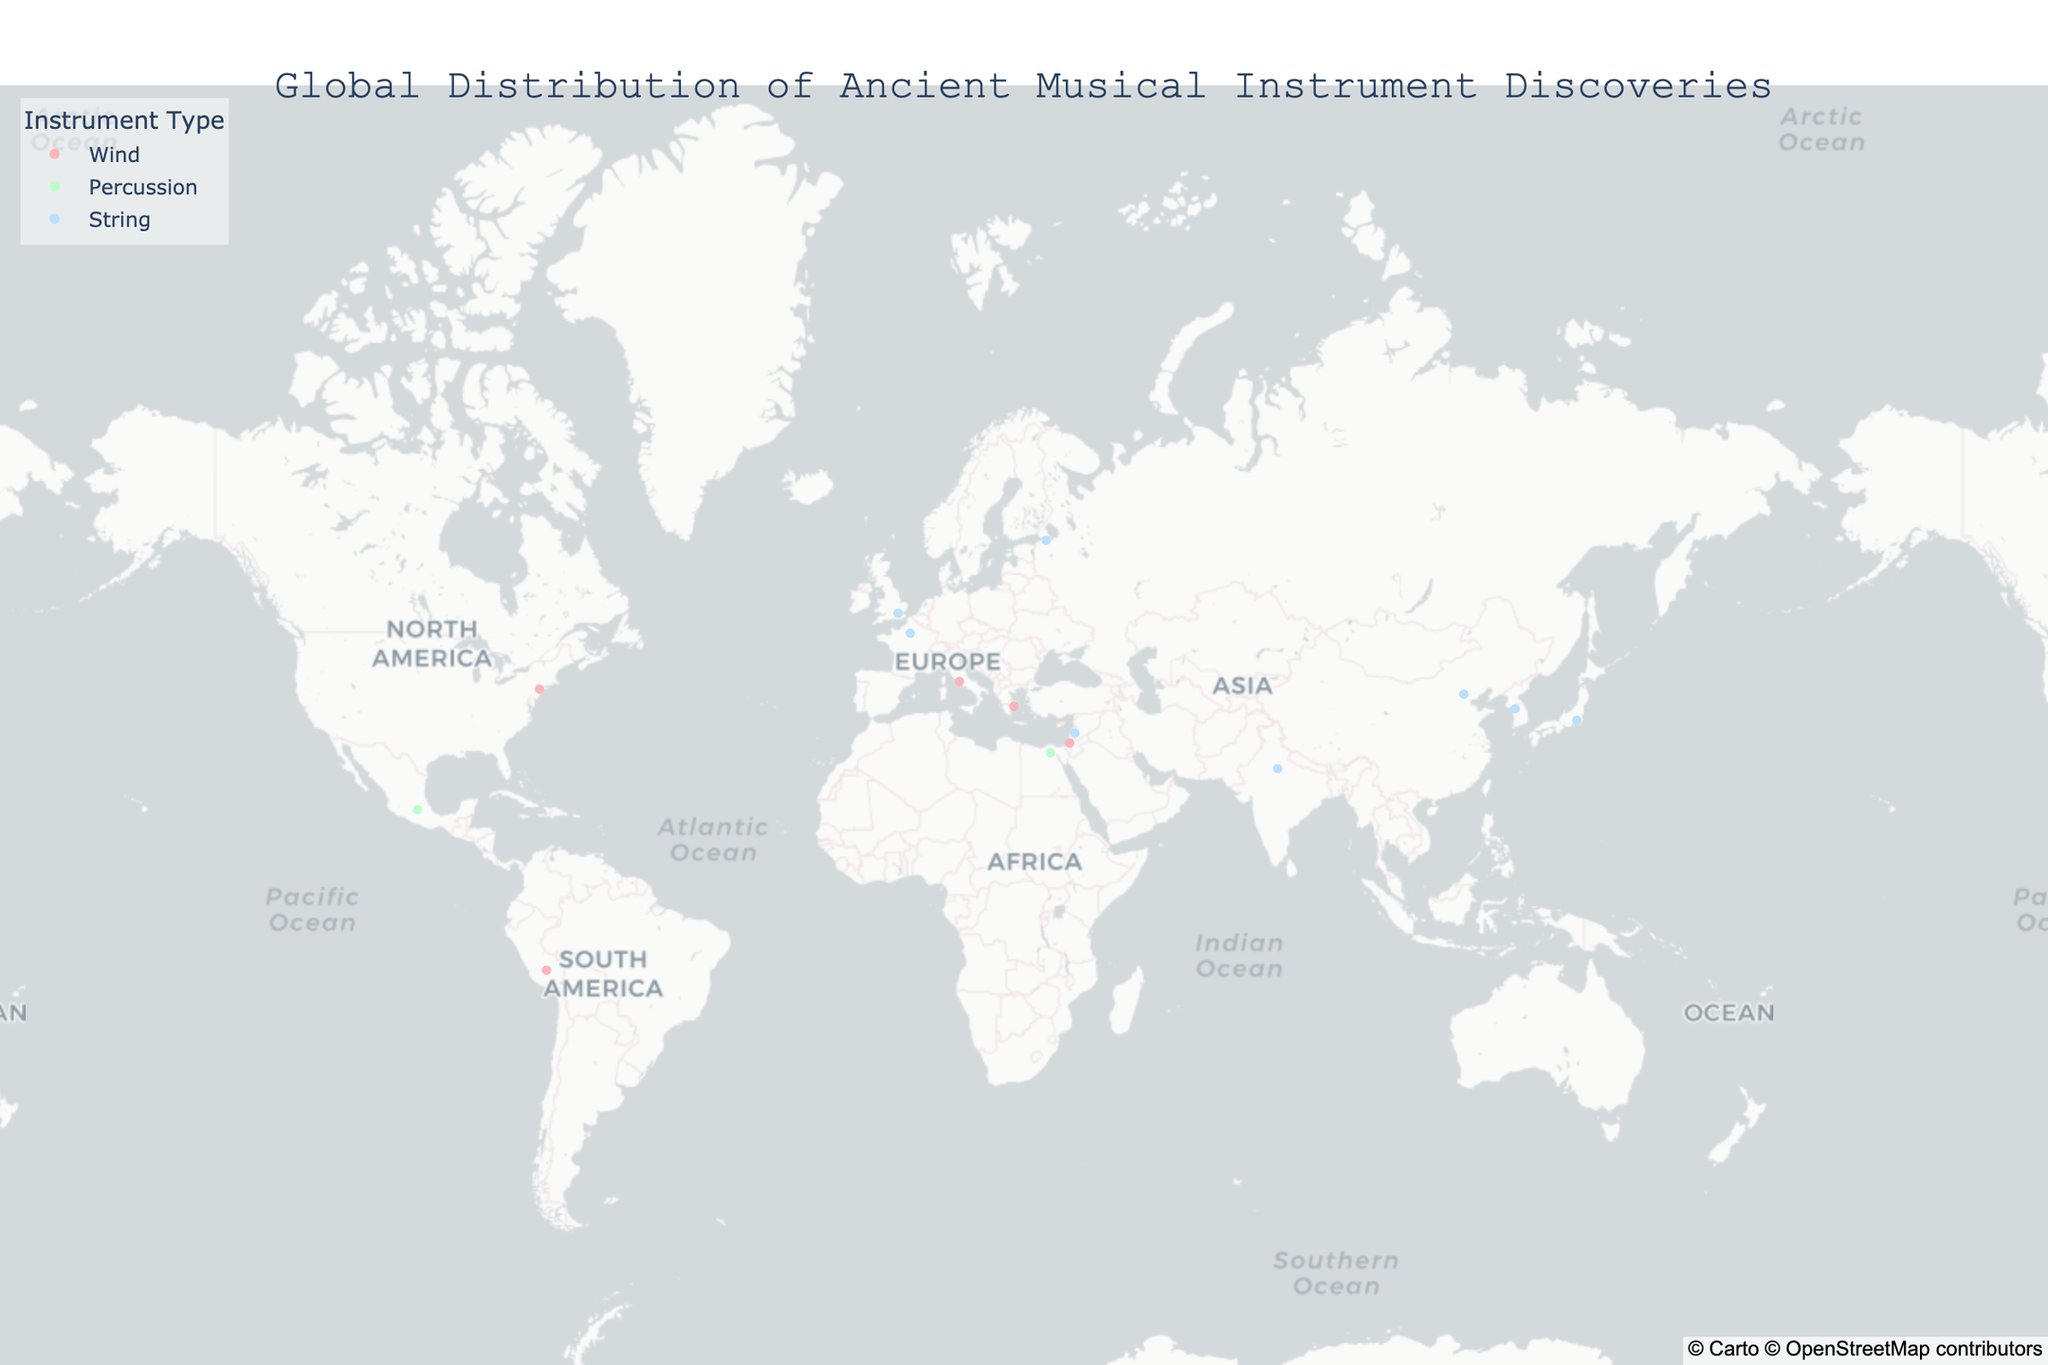What's the title of the figure? The title is located at the top center of the figure and usually describes the main topic or information represented by the figure.
Answer: Global Distribution of Ancient Musical Instrument Discoveries How many different instrument types are represented in the figure? The legend on the right side of the figure shows different colors representing the various instrument types. By counting these, we can see three different types: Wind, Percussion, String.
Answer: Three Which region has the largest number of discoveries? To determine this, we can count the number of markers (data points) within each region on the map. Europe has the most markers.
Answer: Europe What is the period of the Teponaztli instrument? By hovering over the data point in Mexico, associated with the Teponaztli instrument, the figure displays detailed information including its period. It shows that Teponaztli is from the Aztec period.
Answer: Aztec Which continent has the fewest instrument discoveries? By visually scanning and counting the data points on each continent, we can observe which one has the least number. Africa has the fewest with just one discovery.
Answer: Africa Which instrument discovery is found closest to latitude 35°N and longitude 139°E? By looking at the map data points around the coordinates provided, we find the closest discovery is the Biwa in Ancient Japan.
Answer: Biwa Compare the number of String instruments discovered in Asia and Europe. Which has more? By counting the marker points for String instruments in both continents from the map, Asia has four (Guqin, Gayageum, Biwa, Veena) while Europe has three (Lyre, Gusli, Crwth).
Answer: Asia Which period has the highest number of instrument discoveries? By looking at the hover data for all markers, we aggregate the counts for each period. The Ancient periods (Greece, Rome, Egypt, India, China, Korea, Mesopotamia, Israel, Japan) combined have the most, particularly when counting them under a unified "Ancient" category.
Answer: Ancient periods Identify an instrument associated with wind from the Middle East. By examining the hover information for the Middle East region's data points, we see the Shofar in Ancient Israel is a wind instrument.
Answer: Shofar What is the color representation for Percussion instruments in the figure? The legend indicates which colors correspond to which instrument types. Percussion instruments are colored with a light green shade.
Answer: Light green 